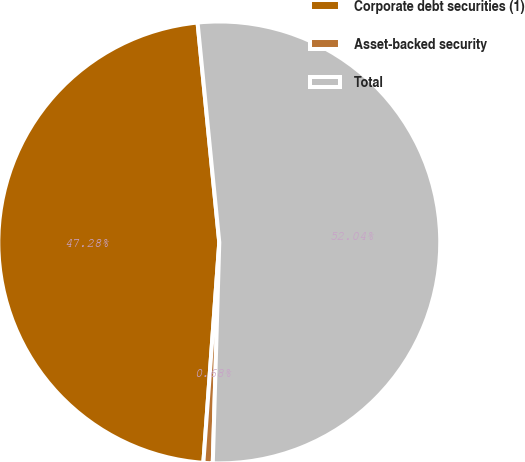Convert chart to OTSL. <chart><loc_0><loc_0><loc_500><loc_500><pie_chart><fcel>Corporate debt securities (1)<fcel>Asset-backed security<fcel>Total<nl><fcel>47.28%<fcel>0.68%<fcel>52.03%<nl></chart> 